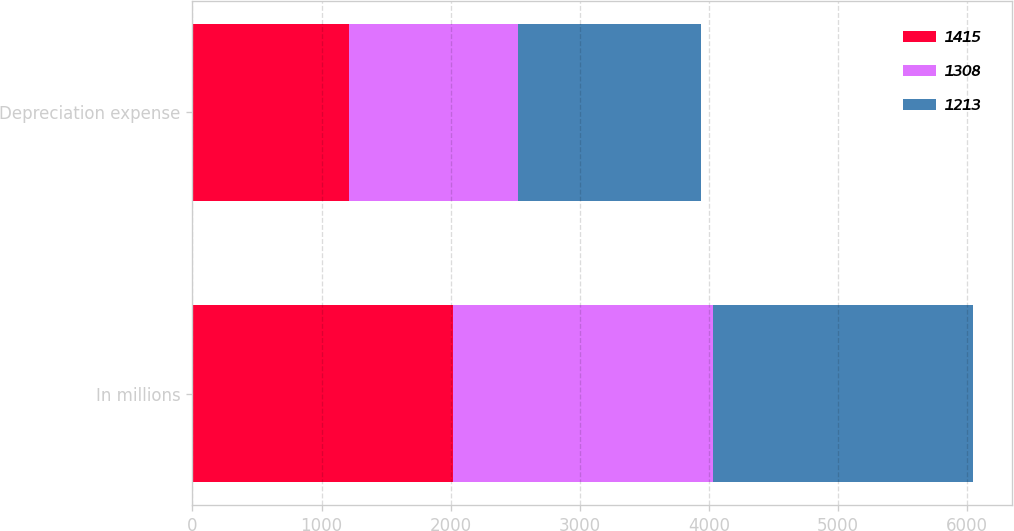Convert chart. <chart><loc_0><loc_0><loc_500><loc_500><stacked_bar_chart><ecel><fcel>In millions<fcel>Depreciation expense<nl><fcel>1415<fcel>2015<fcel>1213<nl><fcel>1308<fcel>2014<fcel>1308<nl><fcel>1213<fcel>2013<fcel>1415<nl></chart> 